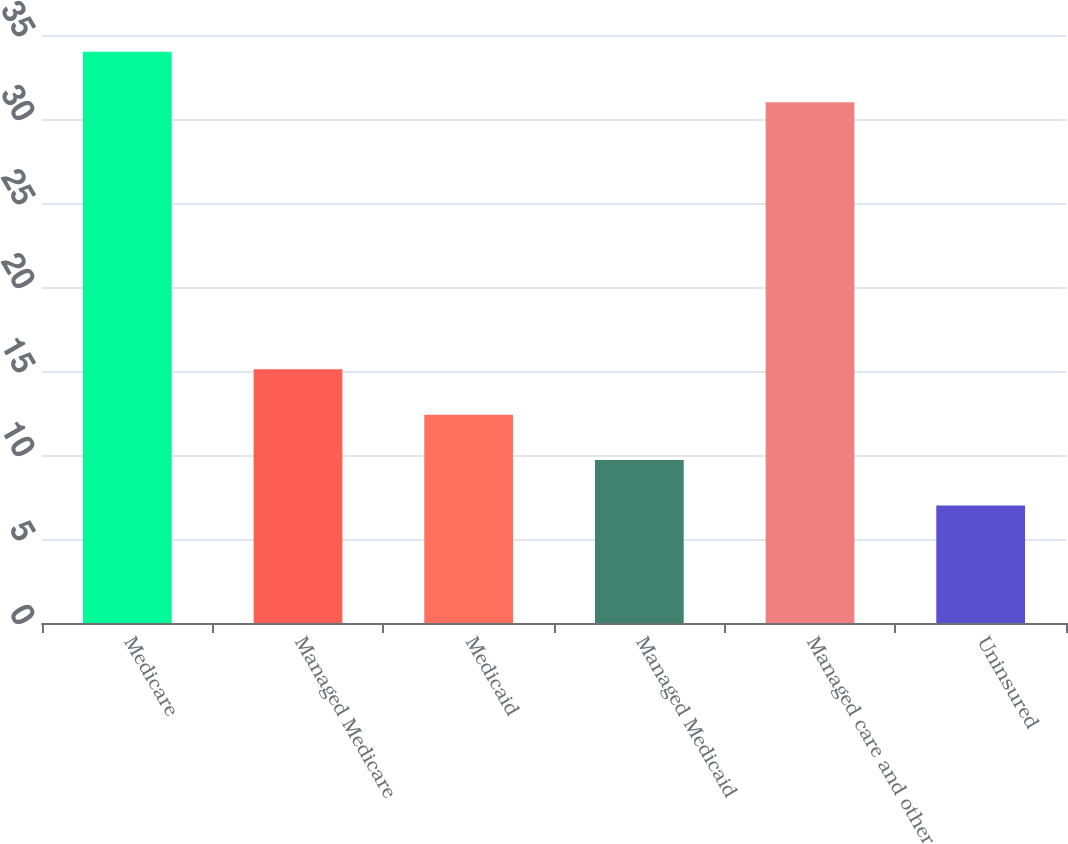Convert chart to OTSL. <chart><loc_0><loc_0><loc_500><loc_500><bar_chart><fcel>Medicare<fcel>Managed Medicare<fcel>Medicaid<fcel>Managed Medicaid<fcel>Managed care and other<fcel>Uninsured<nl><fcel>34<fcel>15.1<fcel>12.4<fcel>9.7<fcel>31<fcel>7<nl></chart> 